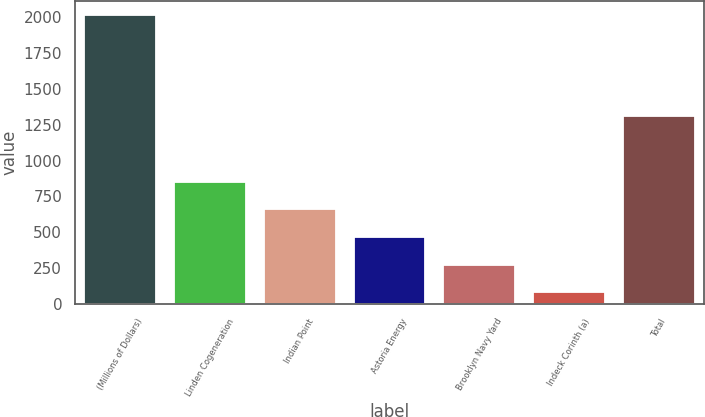<chart> <loc_0><loc_0><loc_500><loc_500><bar_chart><fcel>(Millions of Dollars)<fcel>Linden Cogeneration<fcel>Indian Point<fcel>Astoria Energy<fcel>Brooklyn Navy Yard<fcel>Indeck Corinth (a)<fcel>Total<nl><fcel>2014<fcel>853.6<fcel>660.2<fcel>466.8<fcel>273.4<fcel>80<fcel>1312<nl></chart> 